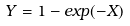<formula> <loc_0><loc_0><loc_500><loc_500>Y = 1 - e x p ( - X )</formula> 